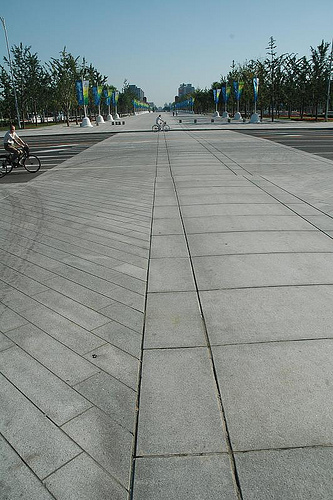<image>
Is the cycle in the road? Yes. The cycle is contained within or inside the road, showing a containment relationship. 